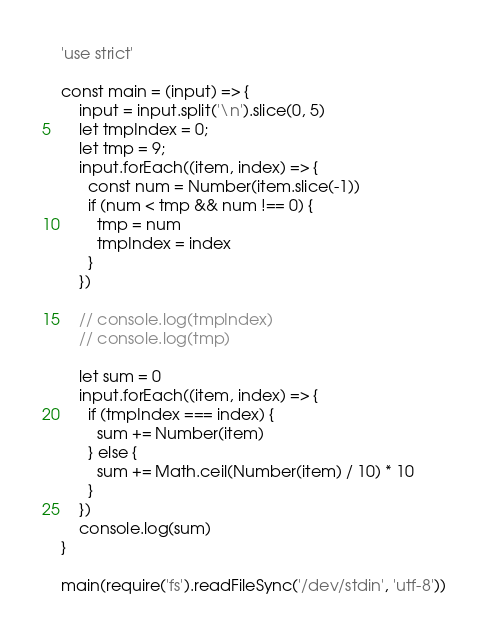<code> <loc_0><loc_0><loc_500><loc_500><_JavaScript_>'use strict'

const main = (input) => {
    input = input.split('\n').slice(0, 5)
    let tmpIndex = 0;
    let tmp = 9;
    input.forEach((item, index) => {
      const num = Number(item.slice(-1))
      if (num < tmp && num !== 0) {
        tmp = num
        tmpIndex = index
      }
    })

    // console.log(tmpIndex)
    // console.log(tmp)

    let sum = 0
    input.forEach((item, index) => {
      if (tmpIndex === index) {
        sum += Number(item)
      } else { 
        sum += Math.ceil(Number(item) / 10) * 10
      }
    })
    console.log(sum)
}

main(require('fs').readFileSync('/dev/stdin', 'utf-8'))</code> 